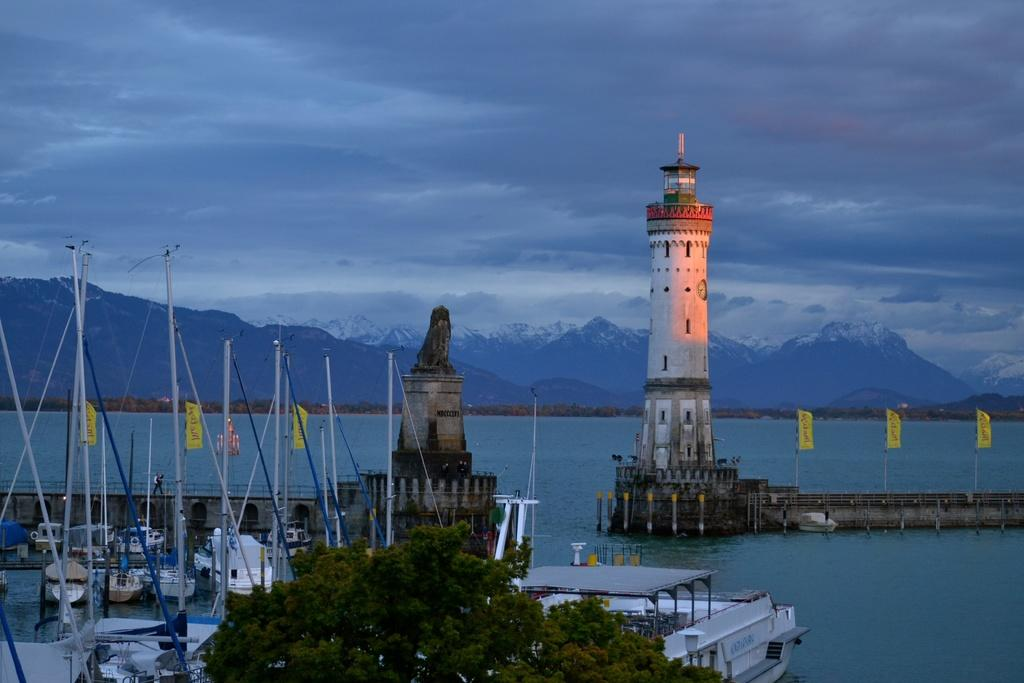What is the main structure in the middle of the image? There is a lighthouse in the middle of the image. What can be seen at the bottom of the image? There are boats at the bottom of the image. What objects are present in the image that are used for support or guidance? There are poles in the image. What type of decorative or symbolic objects can be seen in the image? There are flags in the image. What additional structure is present in the image? There is a statue in the image. What type of natural vegetation is visible in the image? There are trees in the image. What type of natural feature is visible in the image? There is water visible in the image. What type of landscape can be seen in the background of the image? There are hills in the background of the image. What is visible in the sky in the background of the image? There is sky visible in the background of the image, and there are clouds in the background as well. What type of pot is being used to tell a story in the image? There is no pot or storytelling activity present in the image. What unit of measurement is being used to determine the distance between the lighthouse and the boats? There is no unit of measurement or distance determination activity present in the image. 